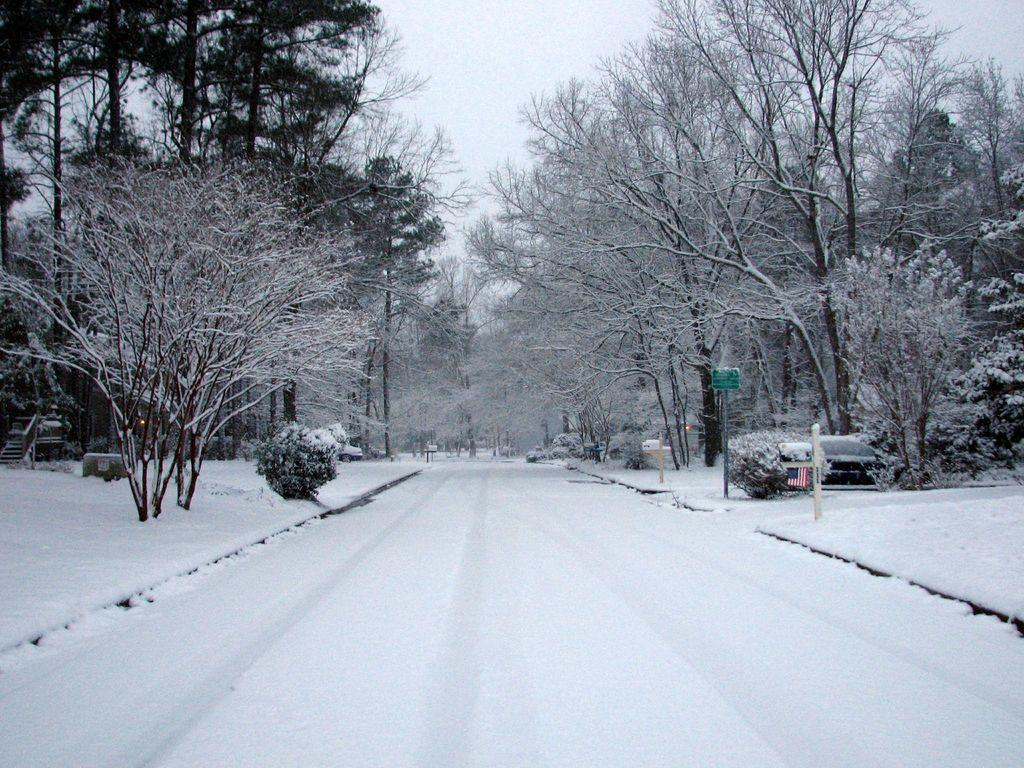What is the main subject of the image? The main subject of the image is an empty road. What can be seen on both sides of the road? There are trees on either side of the road. Are there any vehicles visible in the image? Yes, there are cars parked in the image. How do the waves crash against the shore in the image? There are no waves or shore present in the image; it features an empty road with trees and parked cars. 